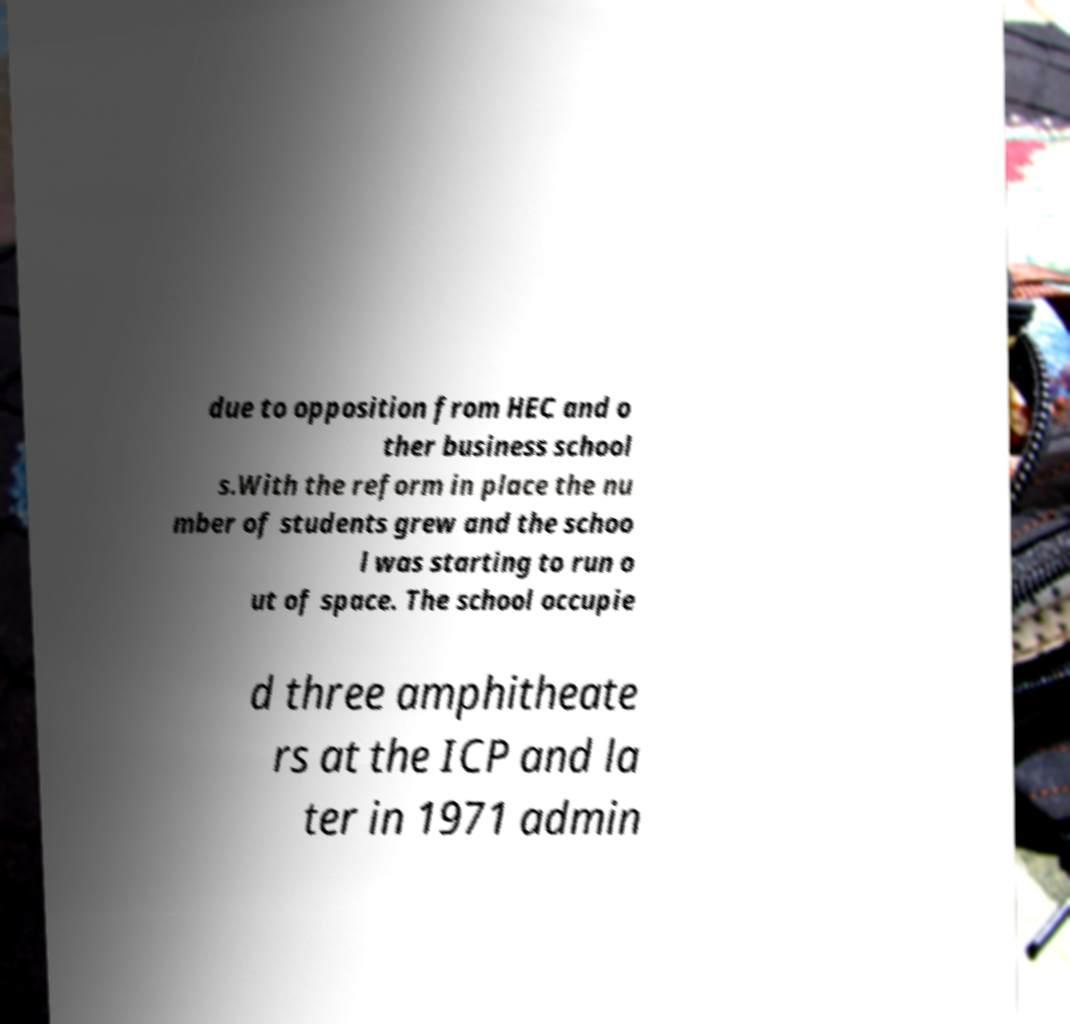I need the written content from this picture converted into text. Can you do that? due to opposition from HEC and o ther business school s.With the reform in place the nu mber of students grew and the schoo l was starting to run o ut of space. The school occupie d three amphitheate rs at the ICP and la ter in 1971 admin 